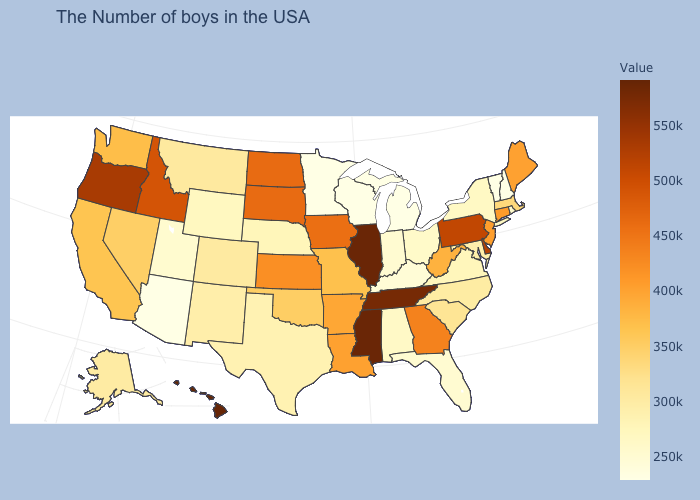Among the states that border Colorado , which have the highest value?
Short answer required. Kansas. Which states have the lowest value in the USA?
Be succinct. New Hampshire, Vermont, Michigan, Wisconsin, Minnesota, Arizona. Is the legend a continuous bar?
Give a very brief answer. Yes. Does the map have missing data?
Concise answer only. No. Does Pennsylvania have the lowest value in the Northeast?
Answer briefly. No. 